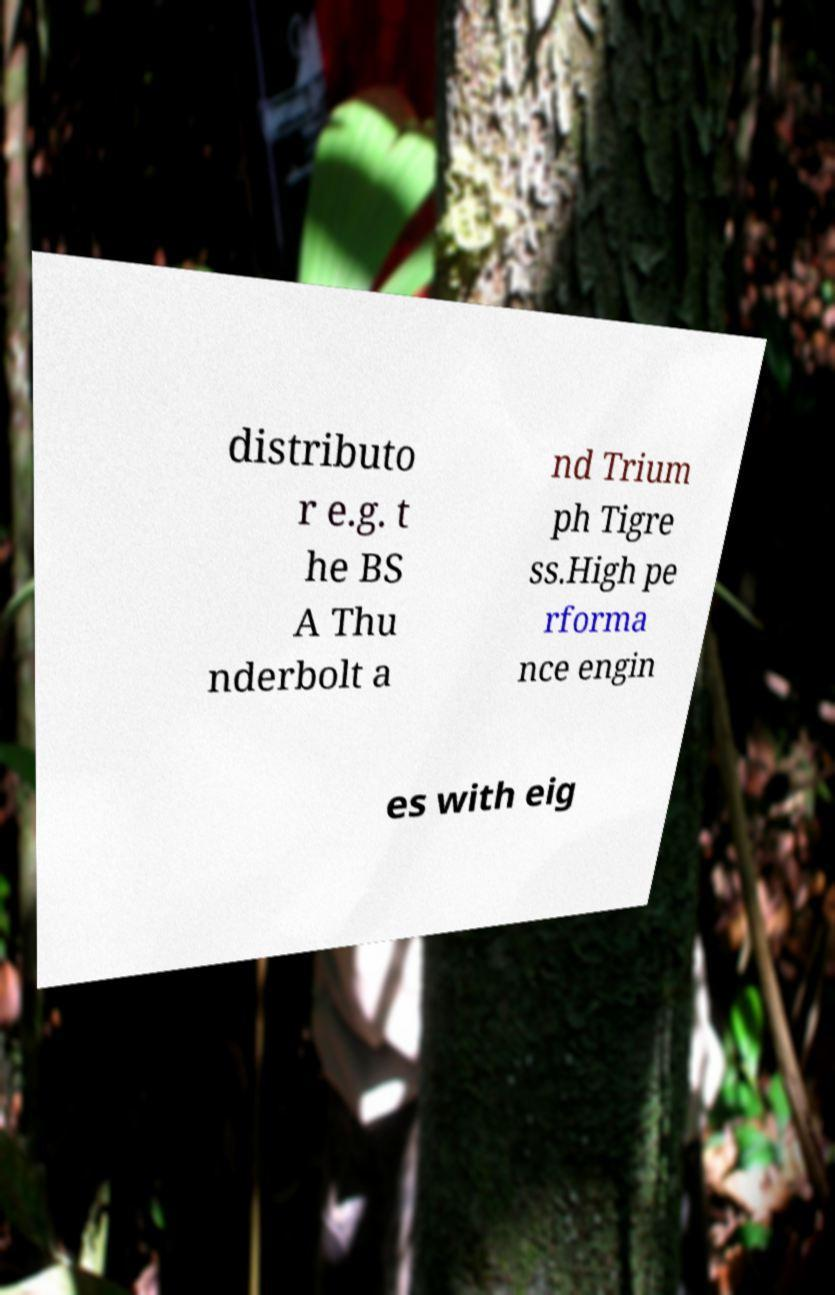Can you read and provide the text displayed in the image?This photo seems to have some interesting text. Can you extract and type it out for me? distributo r e.g. t he BS A Thu nderbolt a nd Trium ph Tigre ss.High pe rforma nce engin es with eig 